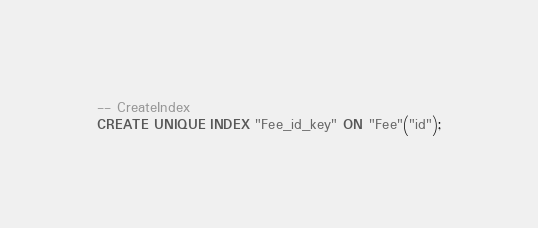Convert code to text. <code><loc_0><loc_0><loc_500><loc_500><_SQL_>
-- CreateIndex
CREATE UNIQUE INDEX "Fee_id_key" ON "Fee"("id");
</code> 